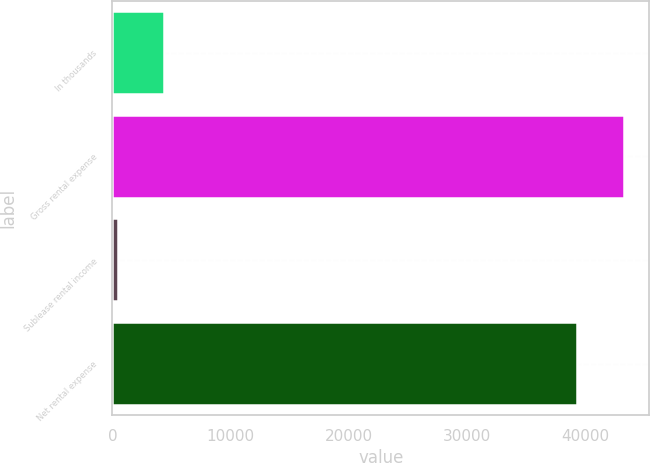Convert chart. <chart><loc_0><loc_0><loc_500><loc_500><bar_chart><fcel>In thousands<fcel>Gross rental expense<fcel>Sublease rental income<fcel>Net rental expense<nl><fcel>4390.3<fcel>43288.3<fcel>455<fcel>39353<nl></chart> 